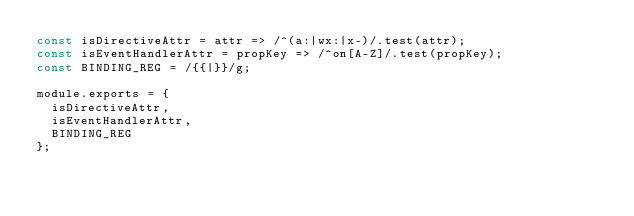<code> <loc_0><loc_0><loc_500><loc_500><_JavaScript_>const isDirectiveAttr = attr => /^(a:|wx:|x-)/.test(attr);
const isEventHandlerAttr = propKey => /^on[A-Z]/.test(propKey);
const BINDING_REG = /{{|}}/g;

module.exports = {
  isDirectiveAttr,
  isEventHandlerAttr,
  BINDING_REG
};
</code> 